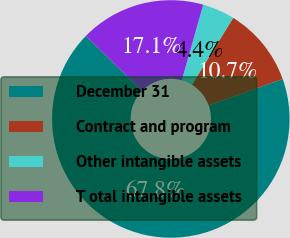Convert chart. <chart><loc_0><loc_0><loc_500><loc_500><pie_chart><fcel>December 31<fcel>Contract and program<fcel>Other intangible assets<fcel>T otal intangible assets<nl><fcel>67.79%<fcel>10.74%<fcel>4.4%<fcel>17.08%<nl></chart> 